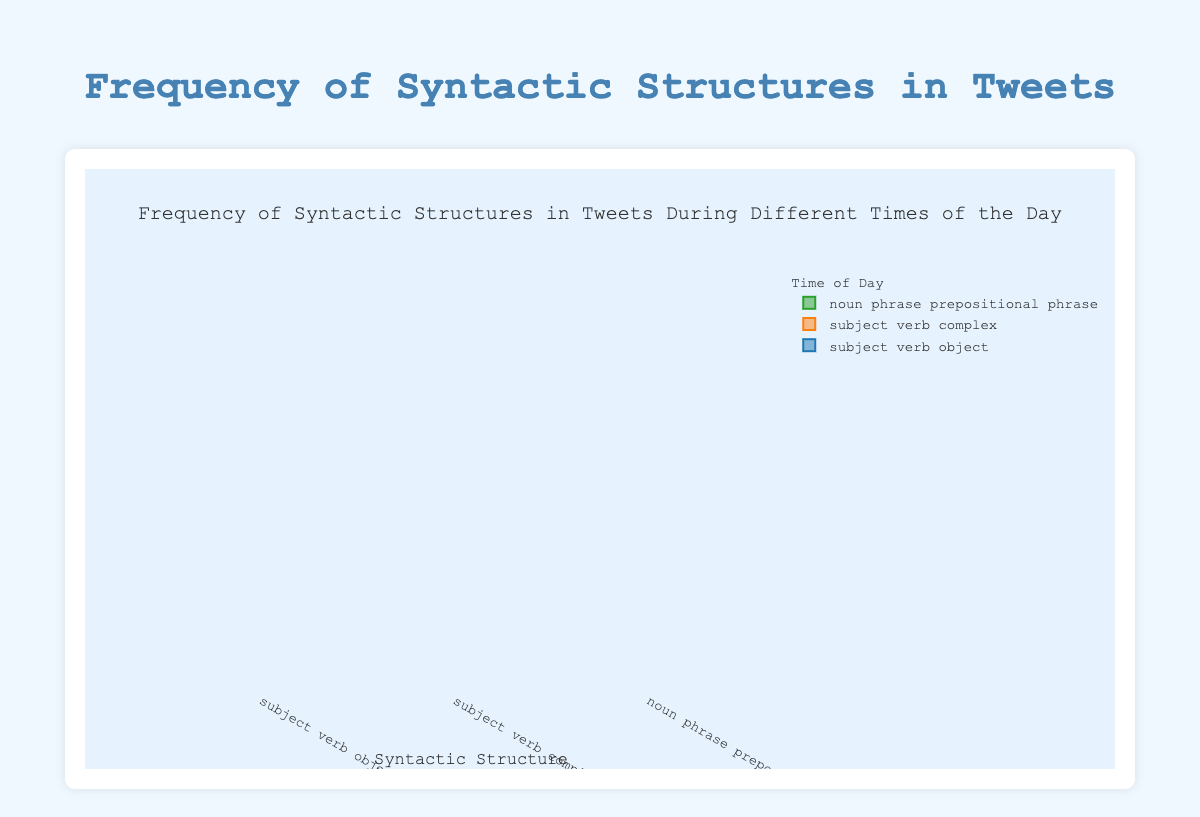Which time of day shows the highest frequency for the "subject verb object" syntactic structure? To determine the highest frequency for the "subject verb object" structure, we compare the frequencies for morning (25), afternoon (30), evening (35), and night (22). The evening with a frequency of 35 is the highest.
Answer: Evening What is the range of frequencies for the "noun phrase prepositional phrase" structure across all times of the day? The frequencies for "noun phrase prepositional phrase" are 20 (morning), 22 (afternoon), 30 (evening), and 21 (night). The smallest value is 20, and the largest is 30, so the range is 30 - 20 = 10.
Answer: 10 Which syntactic structure is most frequently used during the afternoon? To find the most frequently used structure in the afternoon, compare the frequencies: "subject verb object" (30), "subject verb complex" (25), and "noun phrase prepositional phrase" (22). The "subject verb object" with 30 is the highest.
Answer: subject verb object What is the median frequency for the "subject verb complex" structure across all times of day? For the "subject verb complex" structure, the frequencies are 18 (morning), 25 (afternoon), 28 (evening), and 19 (night). Arranging them: 18, 19, 25, 28, the median is the average of the middle two values, (19 + 25) / 2 = 22.
Answer: 22 During which time of day is the variation in frequency for "subject verb object" structure highest compared to other times of the day? By visually comparing the spread (box length) of the "subject verb object" frequencies across different times of day, evening shows more spread with outliers. Exact statistics like variance or standard deviation seem higher for evening compared to other times.
Answer: Evening 